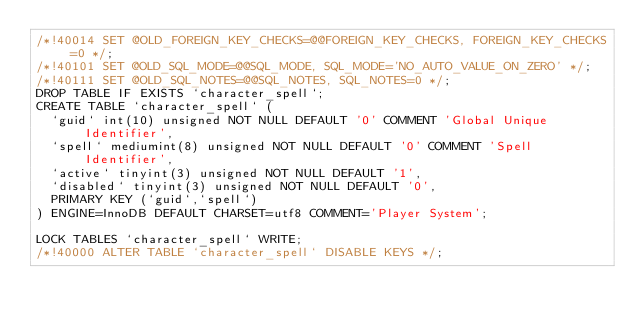Convert code to text. <code><loc_0><loc_0><loc_500><loc_500><_SQL_>/*!40014 SET @OLD_FOREIGN_KEY_CHECKS=@@FOREIGN_KEY_CHECKS, FOREIGN_KEY_CHECKS=0 */;
/*!40101 SET @OLD_SQL_MODE=@@SQL_MODE, SQL_MODE='NO_AUTO_VALUE_ON_ZERO' */;
/*!40111 SET @OLD_SQL_NOTES=@@SQL_NOTES, SQL_NOTES=0 */;
DROP TABLE IF EXISTS `character_spell`;
CREATE TABLE `character_spell` (
  `guid` int(10) unsigned NOT NULL DEFAULT '0' COMMENT 'Global Unique Identifier',
  `spell` mediumint(8) unsigned NOT NULL DEFAULT '0' COMMENT 'Spell Identifier',
  `active` tinyint(3) unsigned NOT NULL DEFAULT '1',
  `disabled` tinyint(3) unsigned NOT NULL DEFAULT '0',
  PRIMARY KEY (`guid`,`spell`)
) ENGINE=InnoDB DEFAULT CHARSET=utf8 COMMENT='Player System';

LOCK TABLES `character_spell` WRITE;
/*!40000 ALTER TABLE `character_spell` DISABLE KEYS */;</code> 